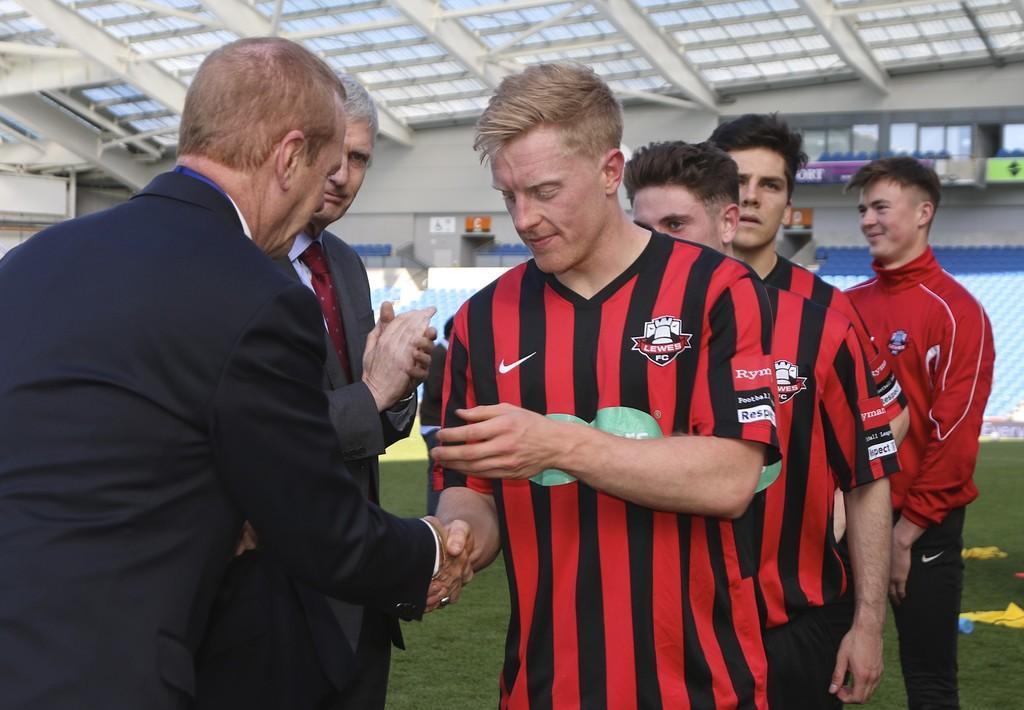In one or two sentences, can you explain what this image depicts? In this image there are some persons standing as we can see in middle of this image and there is a wall in the background. There is a roof on the top of this image. 